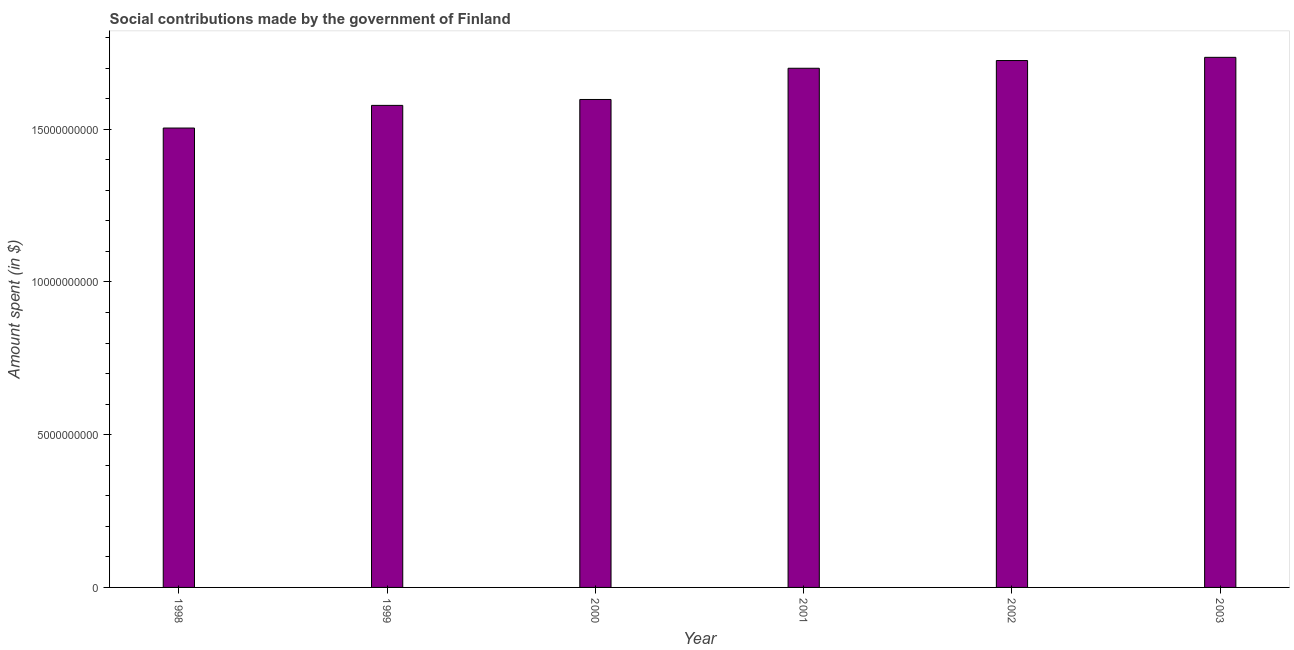What is the title of the graph?
Ensure brevity in your answer.  Social contributions made by the government of Finland. What is the label or title of the X-axis?
Provide a succinct answer. Year. What is the label or title of the Y-axis?
Your response must be concise. Amount spent (in $). What is the amount spent in making social contributions in 2001?
Offer a very short reply. 1.70e+1. Across all years, what is the maximum amount spent in making social contributions?
Your response must be concise. 1.74e+1. Across all years, what is the minimum amount spent in making social contributions?
Provide a short and direct response. 1.50e+1. In which year was the amount spent in making social contributions minimum?
Offer a terse response. 1998. What is the sum of the amount spent in making social contributions?
Your answer should be very brief. 9.84e+1. What is the difference between the amount spent in making social contributions in 1999 and 2003?
Ensure brevity in your answer.  -1.57e+09. What is the average amount spent in making social contributions per year?
Offer a very short reply. 1.64e+1. What is the median amount spent in making social contributions?
Your response must be concise. 1.65e+1. Do a majority of the years between 1998 and 2003 (inclusive) have amount spent in making social contributions greater than 4000000000 $?
Your response must be concise. Yes. What is the ratio of the amount spent in making social contributions in 2000 to that in 2002?
Give a very brief answer. 0.93. Is the amount spent in making social contributions in 1999 less than that in 2000?
Provide a short and direct response. Yes. Is the difference between the amount spent in making social contributions in 1999 and 2001 greater than the difference between any two years?
Your response must be concise. No. What is the difference between the highest and the second highest amount spent in making social contributions?
Your answer should be very brief. 1.05e+08. What is the difference between the highest and the lowest amount spent in making social contributions?
Your answer should be compact. 2.32e+09. How many bars are there?
Ensure brevity in your answer.  6. How many years are there in the graph?
Your response must be concise. 6. What is the Amount spent (in $) in 1998?
Offer a terse response. 1.50e+1. What is the Amount spent (in $) in 1999?
Offer a terse response. 1.58e+1. What is the Amount spent (in $) in 2000?
Your answer should be compact. 1.60e+1. What is the Amount spent (in $) in 2001?
Give a very brief answer. 1.70e+1. What is the Amount spent (in $) in 2002?
Offer a terse response. 1.72e+1. What is the Amount spent (in $) in 2003?
Ensure brevity in your answer.  1.74e+1. What is the difference between the Amount spent (in $) in 1998 and 1999?
Your response must be concise. -7.42e+08. What is the difference between the Amount spent (in $) in 1998 and 2000?
Give a very brief answer. -9.35e+08. What is the difference between the Amount spent (in $) in 1998 and 2001?
Offer a terse response. -1.96e+09. What is the difference between the Amount spent (in $) in 1998 and 2002?
Ensure brevity in your answer.  -2.21e+09. What is the difference between the Amount spent (in $) in 1998 and 2003?
Offer a very short reply. -2.32e+09. What is the difference between the Amount spent (in $) in 1999 and 2000?
Give a very brief answer. -1.93e+08. What is the difference between the Amount spent (in $) in 1999 and 2001?
Provide a short and direct response. -1.22e+09. What is the difference between the Amount spent (in $) in 1999 and 2002?
Keep it short and to the point. -1.47e+09. What is the difference between the Amount spent (in $) in 1999 and 2003?
Provide a short and direct response. -1.57e+09. What is the difference between the Amount spent (in $) in 2000 and 2001?
Make the answer very short. -1.02e+09. What is the difference between the Amount spent (in $) in 2000 and 2002?
Ensure brevity in your answer.  -1.28e+09. What is the difference between the Amount spent (in $) in 2000 and 2003?
Make the answer very short. -1.38e+09. What is the difference between the Amount spent (in $) in 2001 and 2002?
Your answer should be very brief. -2.53e+08. What is the difference between the Amount spent (in $) in 2001 and 2003?
Offer a terse response. -3.58e+08. What is the difference between the Amount spent (in $) in 2002 and 2003?
Offer a terse response. -1.05e+08. What is the ratio of the Amount spent (in $) in 1998 to that in 1999?
Make the answer very short. 0.95. What is the ratio of the Amount spent (in $) in 1998 to that in 2000?
Provide a short and direct response. 0.94. What is the ratio of the Amount spent (in $) in 1998 to that in 2001?
Keep it short and to the point. 0.89. What is the ratio of the Amount spent (in $) in 1998 to that in 2002?
Your answer should be very brief. 0.87. What is the ratio of the Amount spent (in $) in 1998 to that in 2003?
Your response must be concise. 0.87. What is the ratio of the Amount spent (in $) in 1999 to that in 2000?
Provide a succinct answer. 0.99. What is the ratio of the Amount spent (in $) in 1999 to that in 2001?
Give a very brief answer. 0.93. What is the ratio of the Amount spent (in $) in 1999 to that in 2002?
Keep it short and to the point. 0.92. What is the ratio of the Amount spent (in $) in 1999 to that in 2003?
Your response must be concise. 0.91. What is the ratio of the Amount spent (in $) in 2000 to that in 2002?
Make the answer very short. 0.93. What is the ratio of the Amount spent (in $) in 2000 to that in 2003?
Offer a terse response. 0.92. What is the ratio of the Amount spent (in $) in 2002 to that in 2003?
Offer a very short reply. 0.99. 